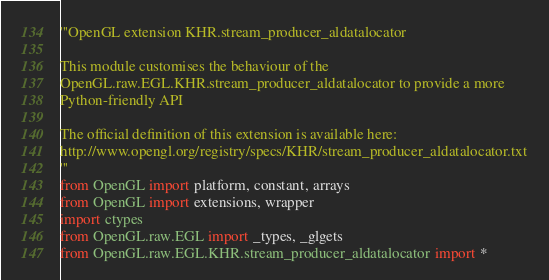Convert code to text. <code><loc_0><loc_0><loc_500><loc_500><_Python_>'''OpenGL extension KHR.stream_producer_aldatalocator

This module customises the behaviour of the 
OpenGL.raw.EGL.KHR.stream_producer_aldatalocator to provide a more 
Python-friendly API

The official definition of this extension is available here:
http://www.opengl.org/registry/specs/KHR/stream_producer_aldatalocator.txt
'''
from OpenGL import platform, constant, arrays
from OpenGL import extensions, wrapper
import ctypes
from OpenGL.raw.EGL import _types, _glgets
from OpenGL.raw.EGL.KHR.stream_producer_aldatalocator import *</code> 